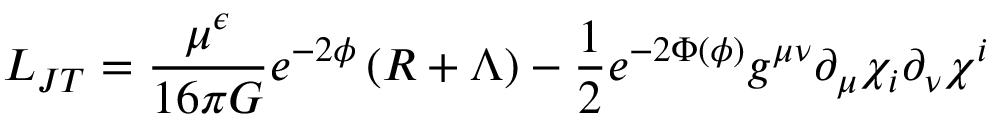Convert formula to latex. <formula><loc_0><loc_0><loc_500><loc_500>L _ { J T } = \frac { \mu ^ { \epsilon } } { 1 6 \pi G } e ^ { - 2 \phi } \left ( R + \Lambda \right ) - { \frac { 1 } { 2 } } e ^ { - 2 \Phi ( \phi ) } g ^ { \mu \nu } \partial _ { \mu } \chi _ { i } \partial _ { \nu } \chi ^ { i }</formula> 